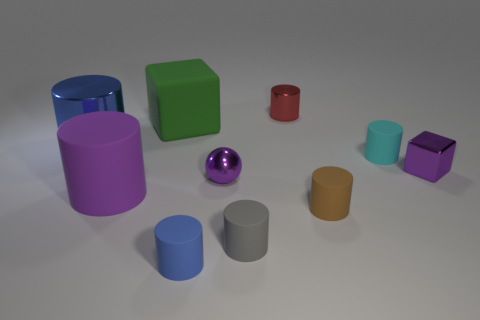Subtract 2 cylinders. How many cylinders are left? 5 Subtract all red cylinders. How many cylinders are left? 6 Subtract all tiny brown cylinders. How many cylinders are left? 6 Subtract all gray cylinders. Subtract all purple spheres. How many cylinders are left? 6 Subtract all blocks. How many objects are left? 8 Subtract 0 blue spheres. How many objects are left? 10 Subtract all tiny rubber objects. Subtract all matte objects. How many objects are left? 0 Add 8 big blue things. How many big blue things are left? 9 Add 5 gray matte cylinders. How many gray matte cylinders exist? 6 